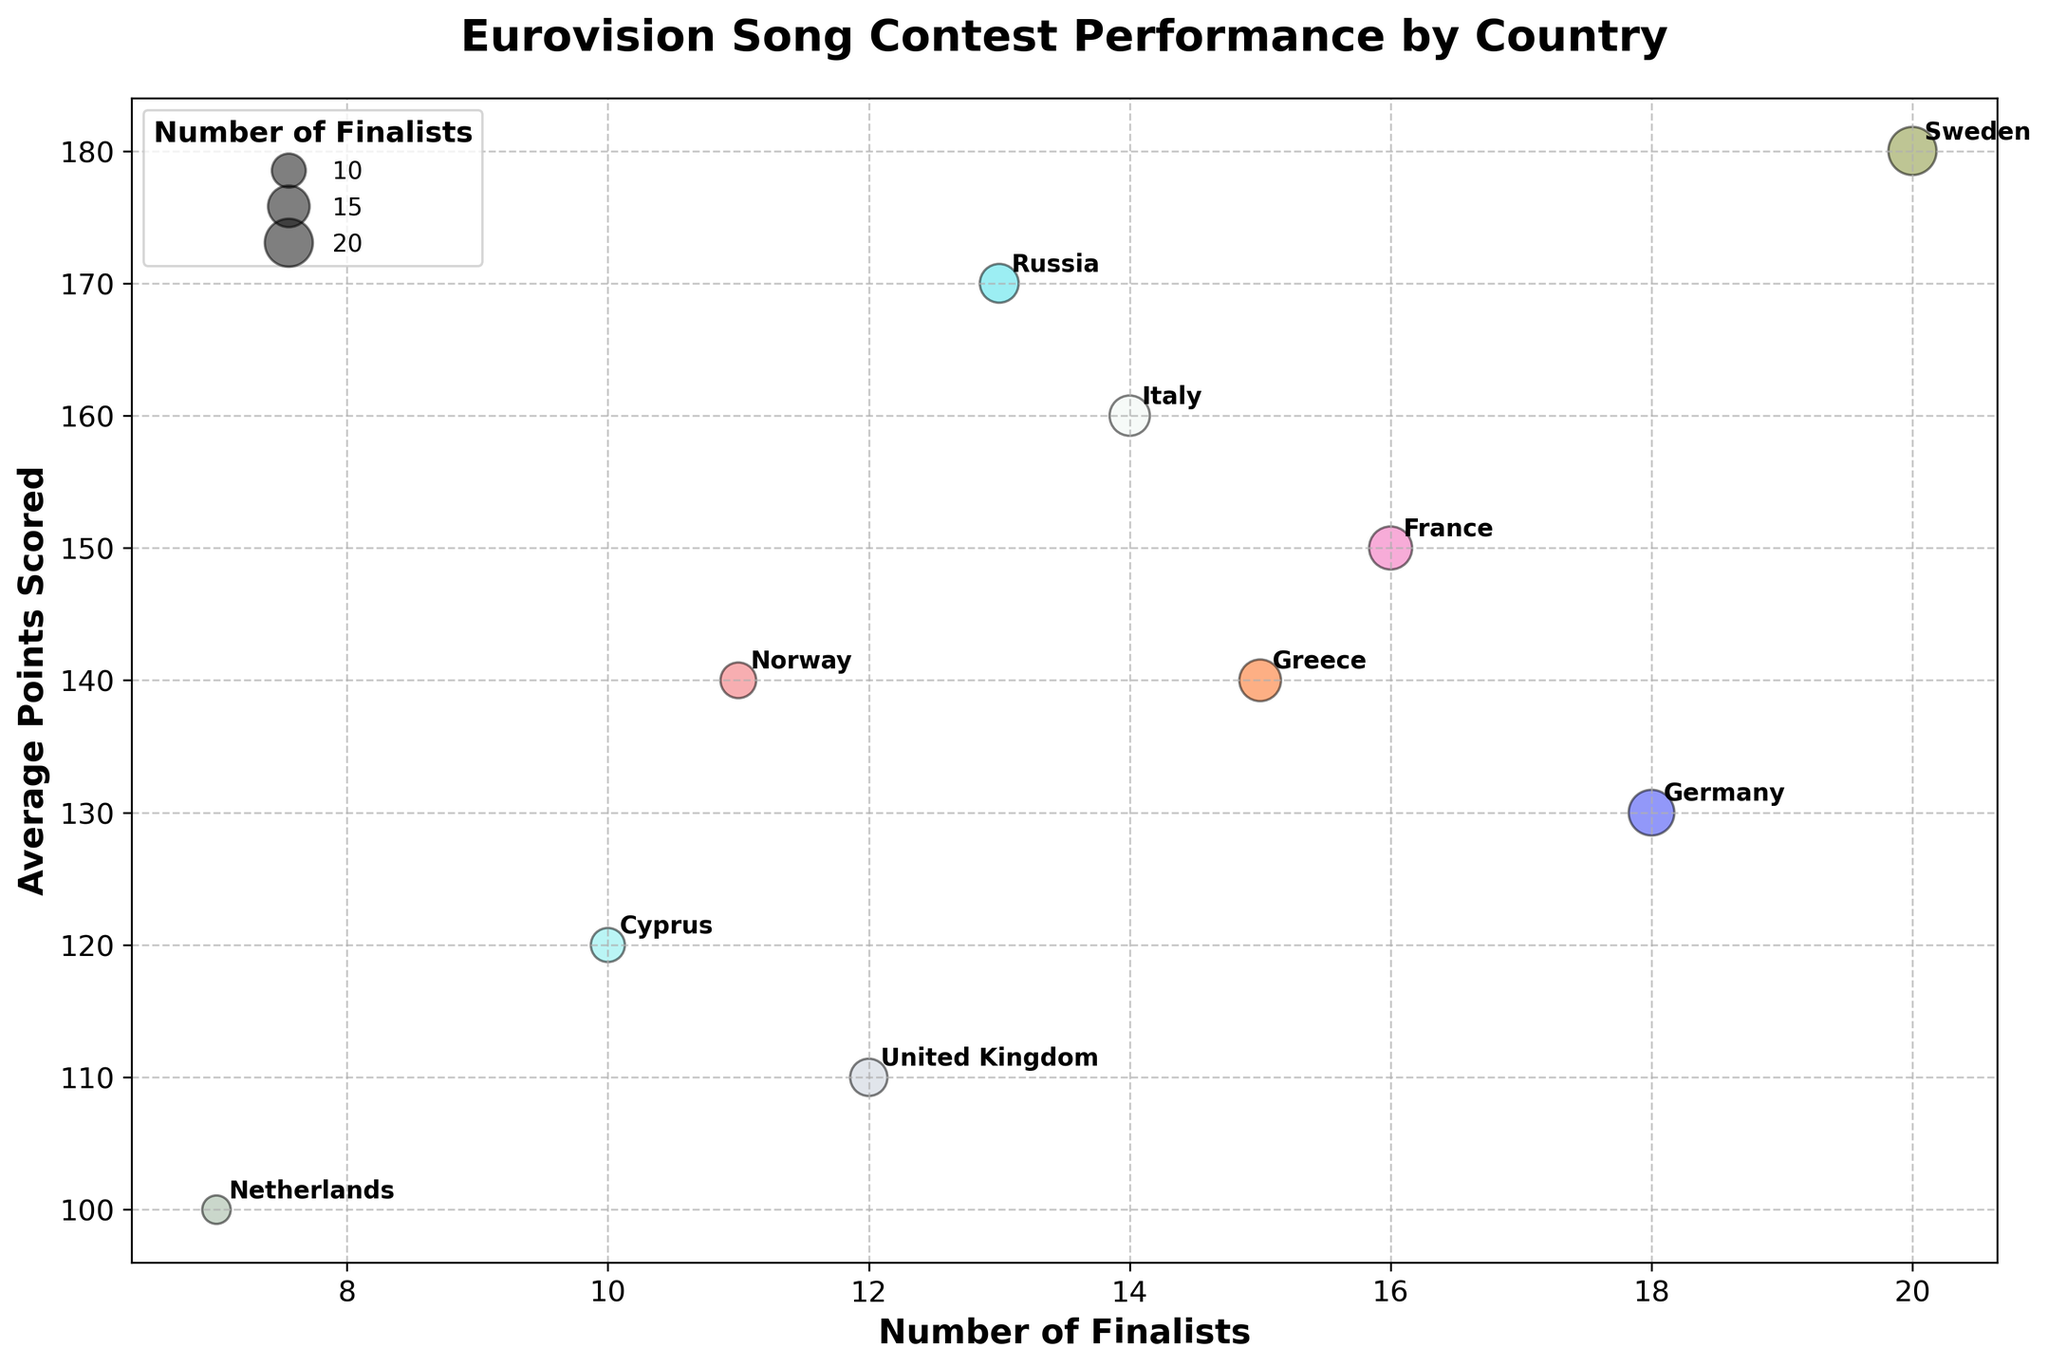How many countries are represented in the bubble chart? There are bubbles for each country listed in the dataset. Counting the number of unique bubbles (annotated with country names), we find the number of countries.
Answer: 10 Which country has the highest average points scored? By looking at the y-axis, we see which bubble reaches the highest value. Sweden's bubble reaches the top at 180 average points.
Answer: Sweden How many finalists does Greece have, and how do they compare in average points scored against Cyprus? Greece has 15 finalists with an average of 140 points, whereas Cyprus has 10 finalists with an average of 120 points. Greece has more finalists and a higher average score compared to Cyprus.
Answer: Greece has more finalists and higher average points What is the average number of finalists among all the countries shown? Sum the number of finalists for all countries: 15+10+20+14+12+18+16+7+13+11, which equals 136. Then divide by the number of countries (10). The average is 136/10.
Answer: 13.6 Which two countries have the closest average points scored, and what are those values? By examining the y-axis positions, Greece and Norway both have an average points scored of 140, making them the closest in average points.
Answer: Greece and Norway (140) What is the difference in average points scored between the United Kingdom and Italy? The UK has an average of 110 points, and Italy has 160. The difference is 160 - 110.
Answer: 50 Which country has the largest bubble on the chart? The size of the bubble is proportional to the number of finalists. Sweden has the largest bubble, indicating the most finalists (20).
Answer: Sweden List countries that have an average score higher than 150. Reviewing the y-axis positions and annotations, Sweden (180), Russia (170), and Italy (160) have average scores higher than 150.
Answer: Sweden, Russia, Italy What are the x and y coordinates for France's bubble on the chart? France's bubble is at the position where "Finalists" is 16 and "Average Points Scored" is 150.
Answer: (16, 150) Compare the average points scored by Germany and France. Which country scored more, and by how much? Germany has an average score of 130, and France has 150. The difference is 150 - 130. France scored more by 20 points.
Answer: France by 20 points 